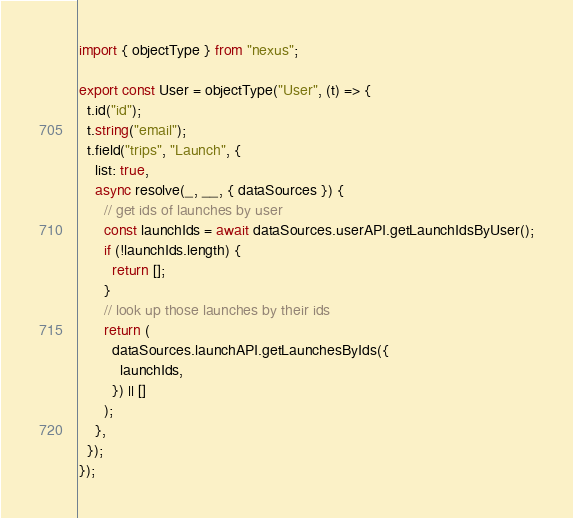Convert code to text. <code><loc_0><loc_0><loc_500><loc_500><_TypeScript_>import { objectType } from "nexus";

export const User = objectType("User", (t) => {
  t.id("id");
  t.string("email");
  t.field("trips", "Launch", {
    list: true,
    async resolve(_, __, { dataSources }) {
      // get ids of launches by user
      const launchIds = await dataSources.userAPI.getLaunchIdsByUser();
      if (!launchIds.length) {
        return [];
      }
      // look up those launches by their ids
      return (
        dataSources.launchAPI.getLaunchesByIds({
          launchIds,
        }) || []
      );
    },
  });
});
</code> 